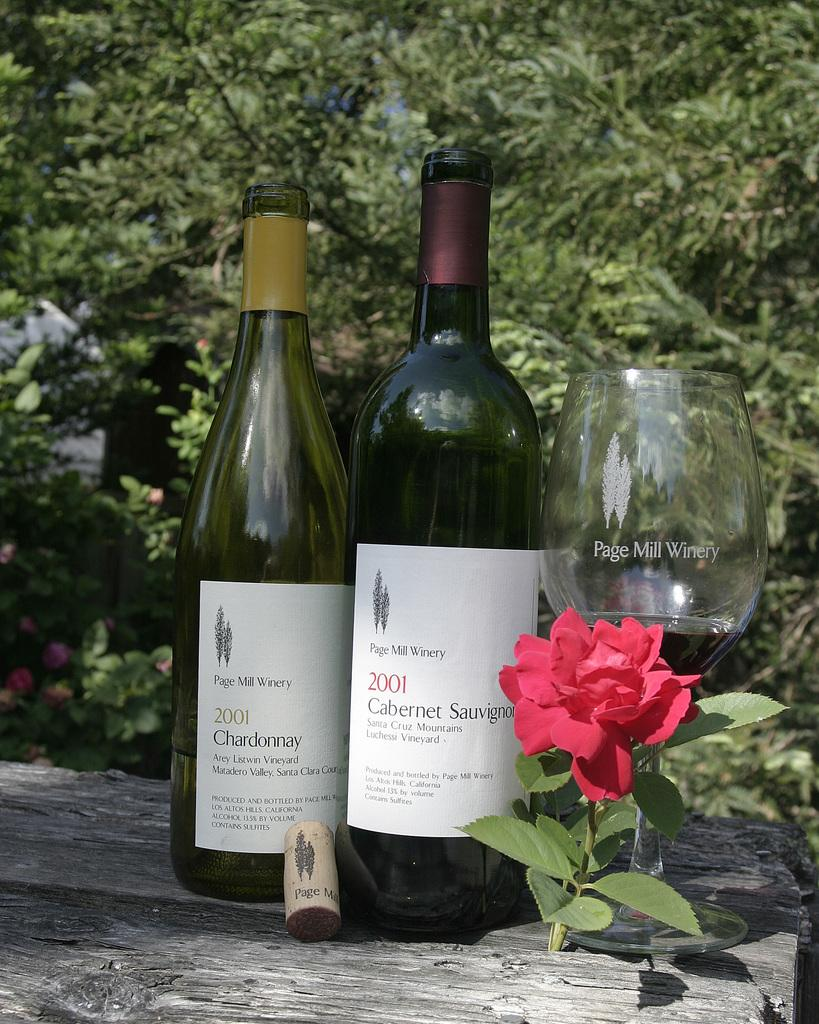Provide a one-sentence caption for the provided image. Page Mill Winery made these great wines in 2001. 